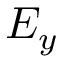Convert formula to latex. <formula><loc_0><loc_0><loc_500><loc_500>E _ { y }</formula> 